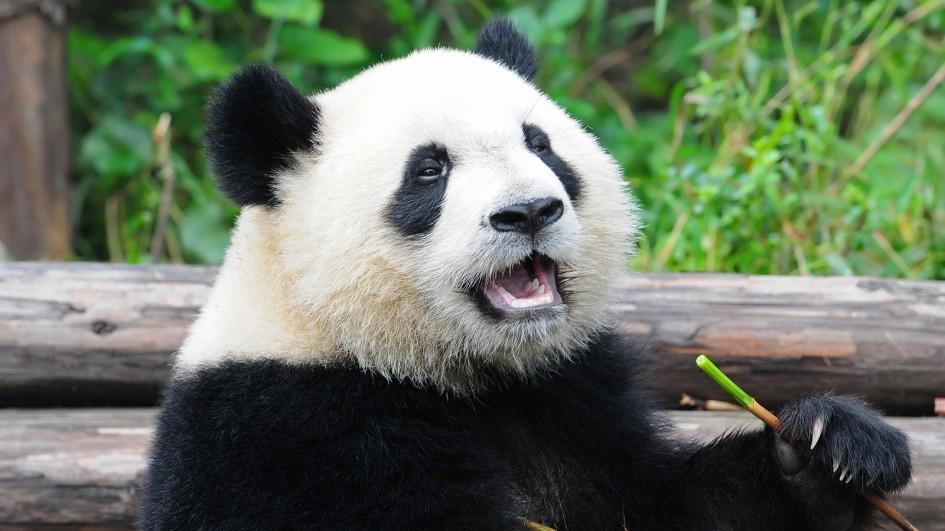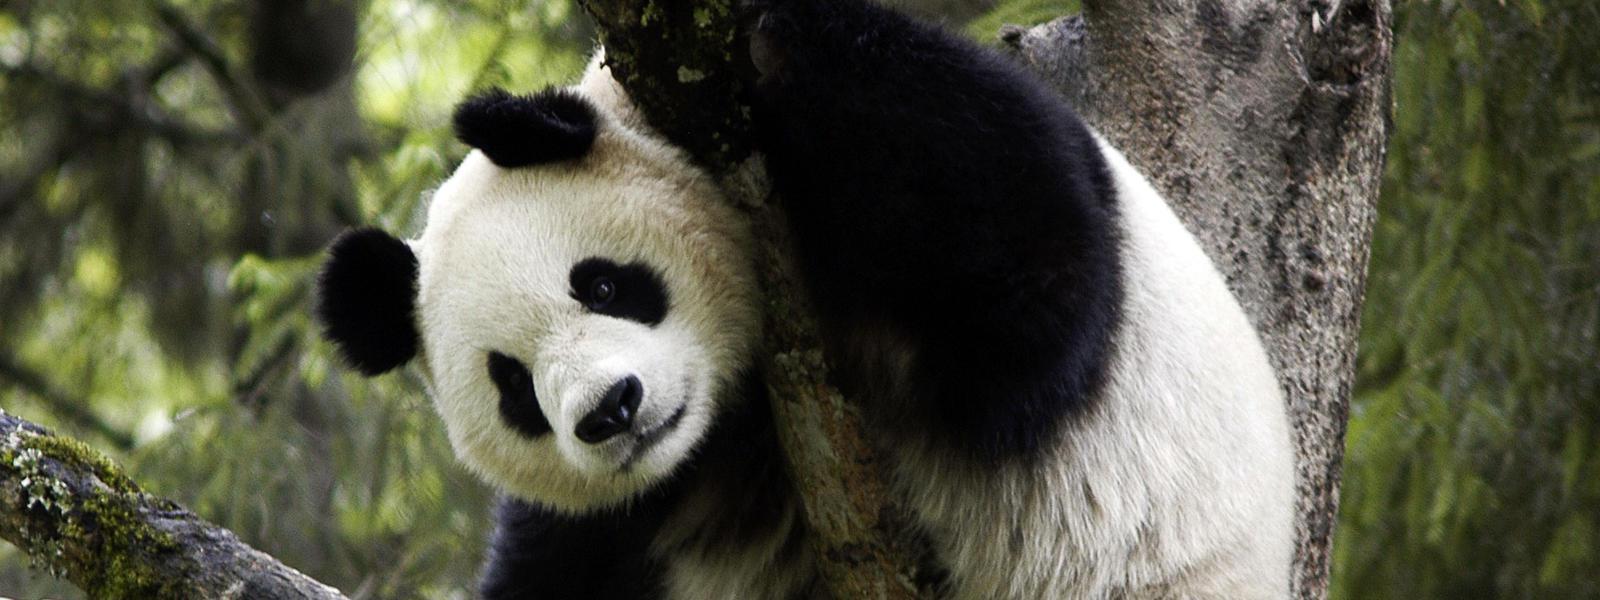The first image is the image on the left, the second image is the image on the right. Given the left and right images, does the statement "An image shows one open-mouthed panda clutching a leafless stalk." hold true? Answer yes or no. Yes. 